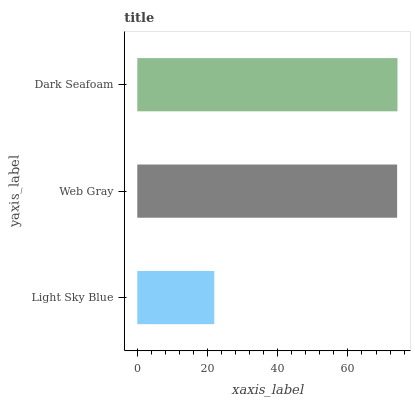Is Light Sky Blue the minimum?
Answer yes or no. Yes. Is Dark Seafoam the maximum?
Answer yes or no. Yes. Is Web Gray the minimum?
Answer yes or no. No. Is Web Gray the maximum?
Answer yes or no. No. Is Web Gray greater than Light Sky Blue?
Answer yes or no. Yes. Is Light Sky Blue less than Web Gray?
Answer yes or no. Yes. Is Light Sky Blue greater than Web Gray?
Answer yes or no. No. Is Web Gray less than Light Sky Blue?
Answer yes or no. No. Is Web Gray the high median?
Answer yes or no. Yes. Is Web Gray the low median?
Answer yes or no. Yes. Is Dark Seafoam the high median?
Answer yes or no. No. Is Dark Seafoam the low median?
Answer yes or no. No. 